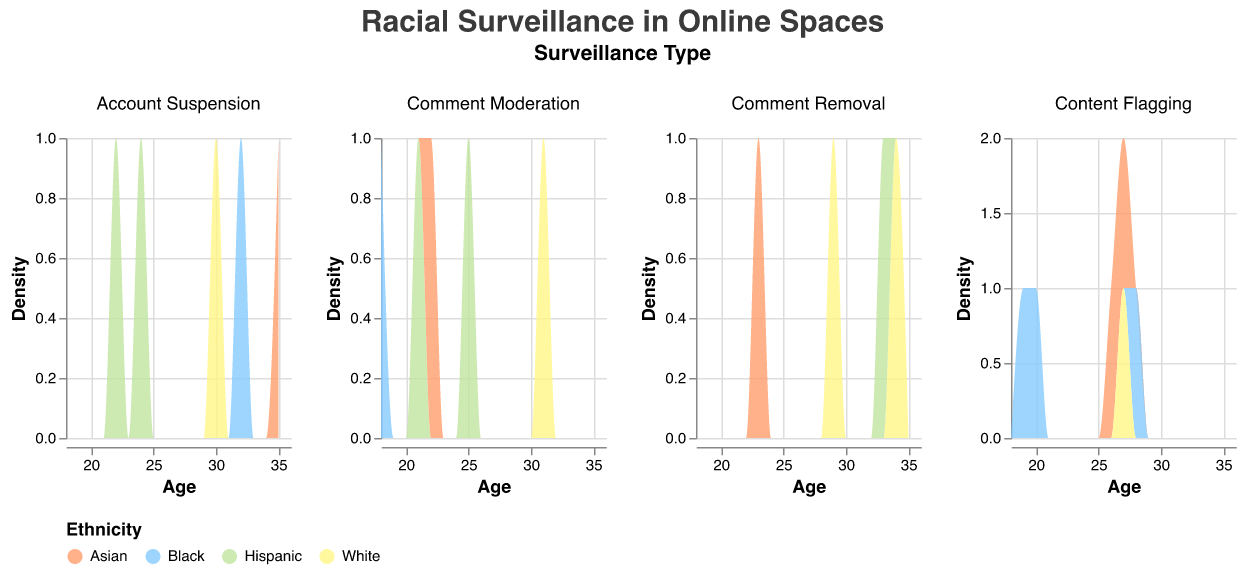What is the title of the figure? The title is displayed at the top center of the figure in a larger font size than the other text, which helps in identifying the main focus of the visualization.
Answer: Racial Surveillance in Online Spaces What surveillance type shows the highest density across the age range of 20-30? By observing the subplot corresponding to the age range of 20-30 in each surveillance type, we compare the height of the density peaks.
Answer: Content Flagging How many different ethnicities are represented in this figure? We examine the legend, which uses distinct colors to represent different ethnicities. Counting these colors gives the total number.
Answer: 4 Which ethnicity has the highest density in the "Content Flagging" surveillance type for users around the age of 27? In the "Content Flagging" subplot, identify the highest peak around age 27 and match the color to the legend.
Answer: Asian Compare the density of "Account Suspension" between Non-binary and Female users. Who has a higher density overall? By viewing the "Account Suspension" subplot, we compare the overall height of the density areas colored for Non-binary and Female users across all ages.
Answer: Non-binary Does the density of "Comment Moderation" differ more by age or ethnicity? By comparing the density shapes across ages and ethnicities in "Comment Moderation" subplot, we determine which factor shows more variation.
Answer: Age Which gender experiences "Content Flagging" most frequently? Examine the heights of the density areas in the "Content Flagging" subplot categorized by gender to identify the highest peak.
Answer: Male For "Account Suspension", which age group shows the highest density for White users? In the "Account Suspension" subplot, locate the peak density for the color corresponding to White users and note the age at which it occurs.
Answer: Around Age 30 Is there any age group where all surveillance types have a significant density? Compare all surveillance type subplots to identify any common age range where significant density peaks are observed across all subplots.
Answer: No 